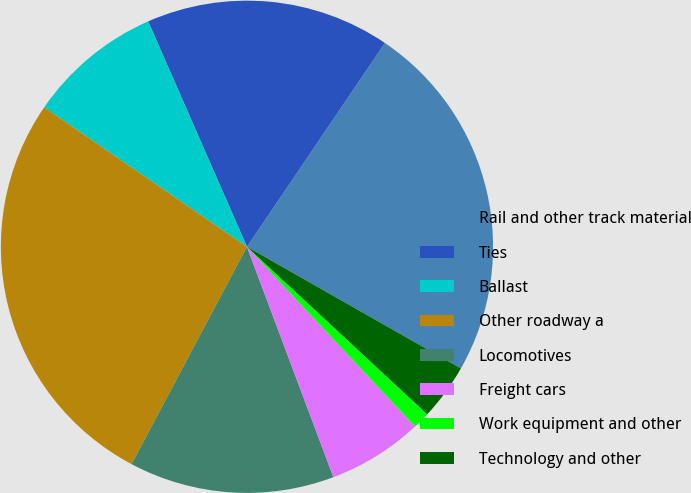Convert chart to OTSL. <chart><loc_0><loc_0><loc_500><loc_500><pie_chart><fcel>Rail and other track material<fcel>Ties<fcel>Ballast<fcel>Other roadway a<fcel>Locomotives<fcel>Freight cars<fcel>Work equipment and other<fcel>Technology and other<nl><fcel>23.76%<fcel>16.05%<fcel>8.83%<fcel>26.83%<fcel>13.48%<fcel>6.26%<fcel>1.11%<fcel>3.69%<nl></chart> 